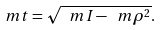<formula> <loc_0><loc_0><loc_500><loc_500>\ m t = \sqrt { \ m I - \ m \rho ^ { 2 } } .</formula> 